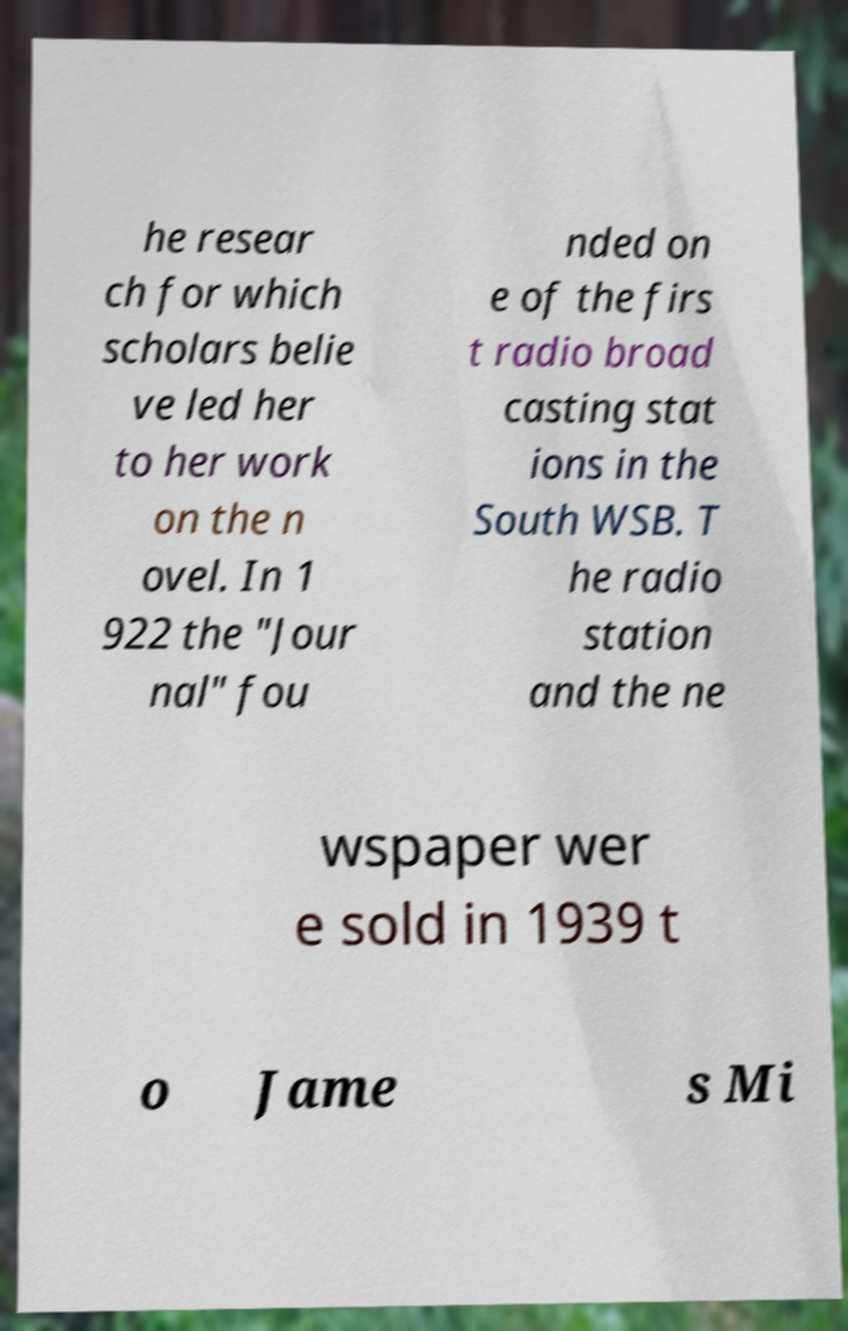Could you assist in decoding the text presented in this image and type it out clearly? he resear ch for which scholars belie ve led her to her work on the n ovel. In 1 922 the "Jour nal" fou nded on e of the firs t radio broad casting stat ions in the South WSB. T he radio station and the ne wspaper wer e sold in 1939 t o Jame s Mi 